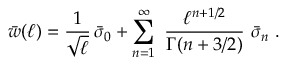<formula> <loc_0><loc_0><loc_500><loc_500>\bar { w } ( \ell ) = { \frac { 1 } { \sqrt { \ell } } } \, \bar { \sigma } _ { 0 } + \sum _ { n = 1 } ^ { \infty } \ { \frac { \ell ^ { n + 1 / 2 } } { \Gamma ( n + 3 / 2 ) } } \ \bar { \sigma } _ { n } \ .</formula> 